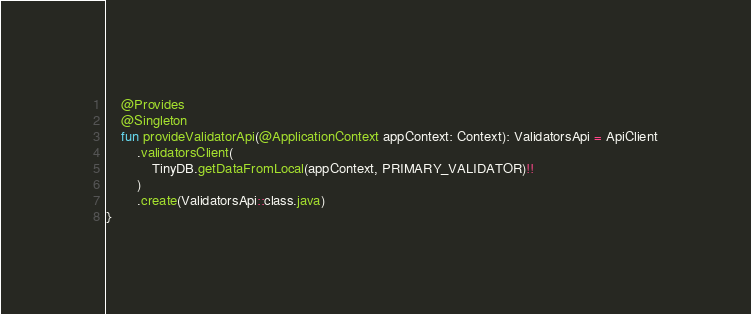Convert code to text. <code><loc_0><loc_0><loc_500><loc_500><_Kotlin_>    @Provides
    @Singleton
    fun provideValidatorApi(@ApplicationContext appContext: Context): ValidatorsApi = ApiClient
        .validatorsClient(
            TinyDB.getDataFromLocal(appContext, PRIMARY_VALIDATOR)!!
        )
        .create(ValidatorsApi::class.java)
}
</code> 